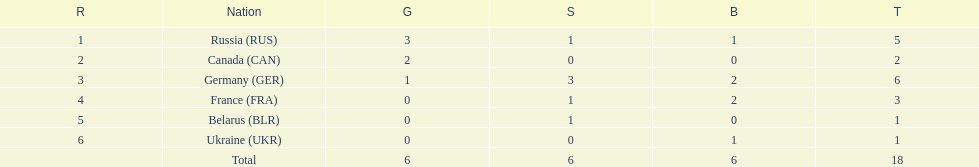Can you give me this table as a dict? {'header': ['R', 'Nation', 'G', 'S', 'B', 'T'], 'rows': [['1', 'Russia\xa0(RUS)', '3', '1', '1', '5'], ['2', 'Canada\xa0(CAN)', '2', '0', '0', '2'], ['3', 'Germany\xa0(GER)', '1', '3', '2', '6'], ['4', 'France\xa0(FRA)', '0', '1', '2', '3'], ['5', 'Belarus\xa0(BLR)', '0', '1', '0', '1'], ['6', 'Ukraine\xa0(UKR)', '0', '0', '1', '1'], ['', 'Total', '6', '6', '6', '18']]} What country had the most medals total at the the 1994 winter olympics biathlon? Germany (GER). 